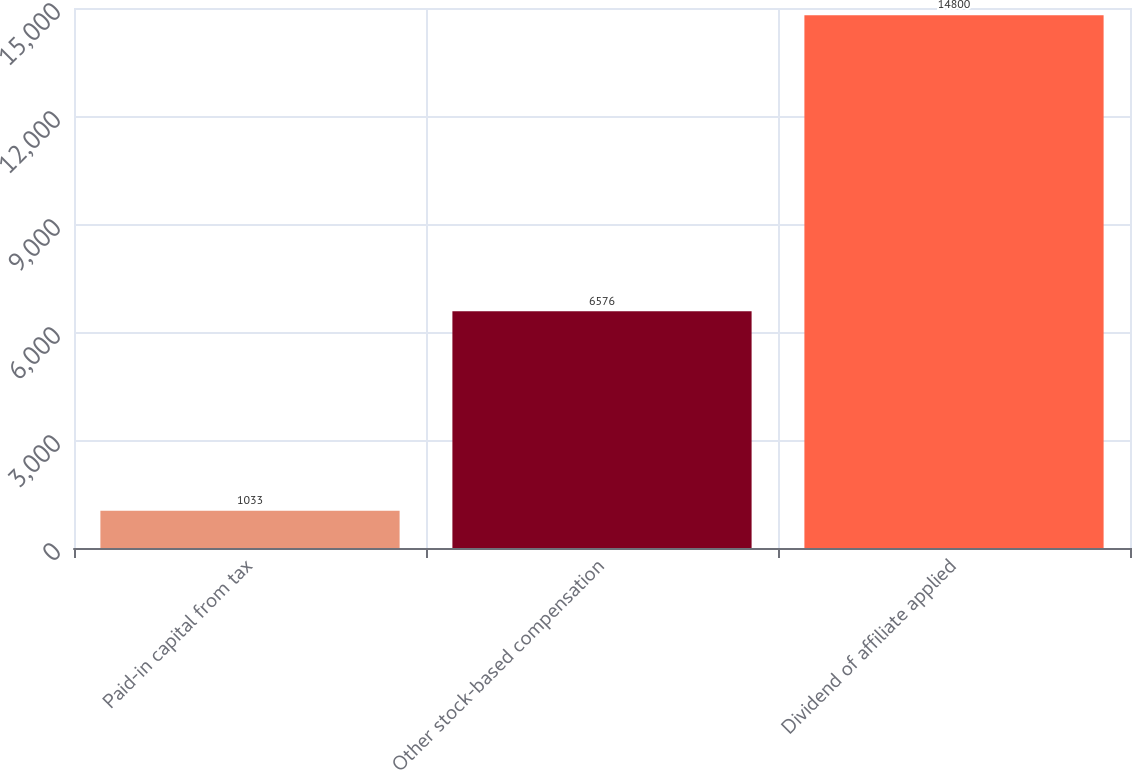Convert chart. <chart><loc_0><loc_0><loc_500><loc_500><bar_chart><fcel>Paid-in capital from tax<fcel>Other stock-based compensation<fcel>Dividend of affiliate applied<nl><fcel>1033<fcel>6576<fcel>14800<nl></chart> 